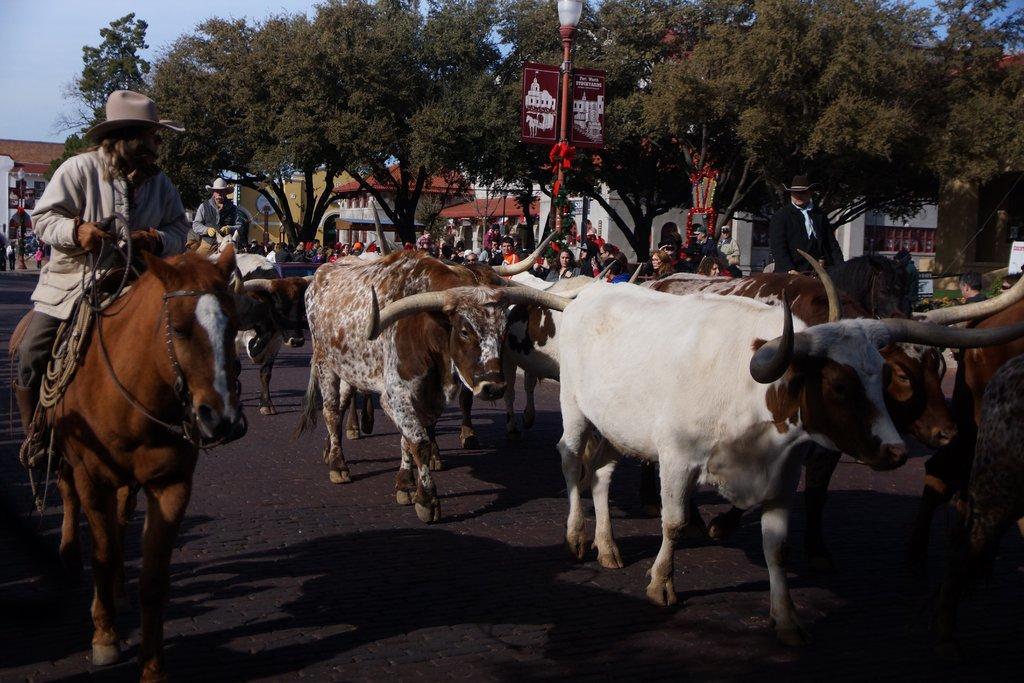In one or two sentences, can you explain what this image depicts? In this image I can see animals. There are people sitting on the horses. Also there are buildings, trees, name boards, group of people and in the background there is sky. 